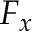Convert formula to latex. <formula><loc_0><loc_0><loc_500><loc_500>F _ { x }</formula> 